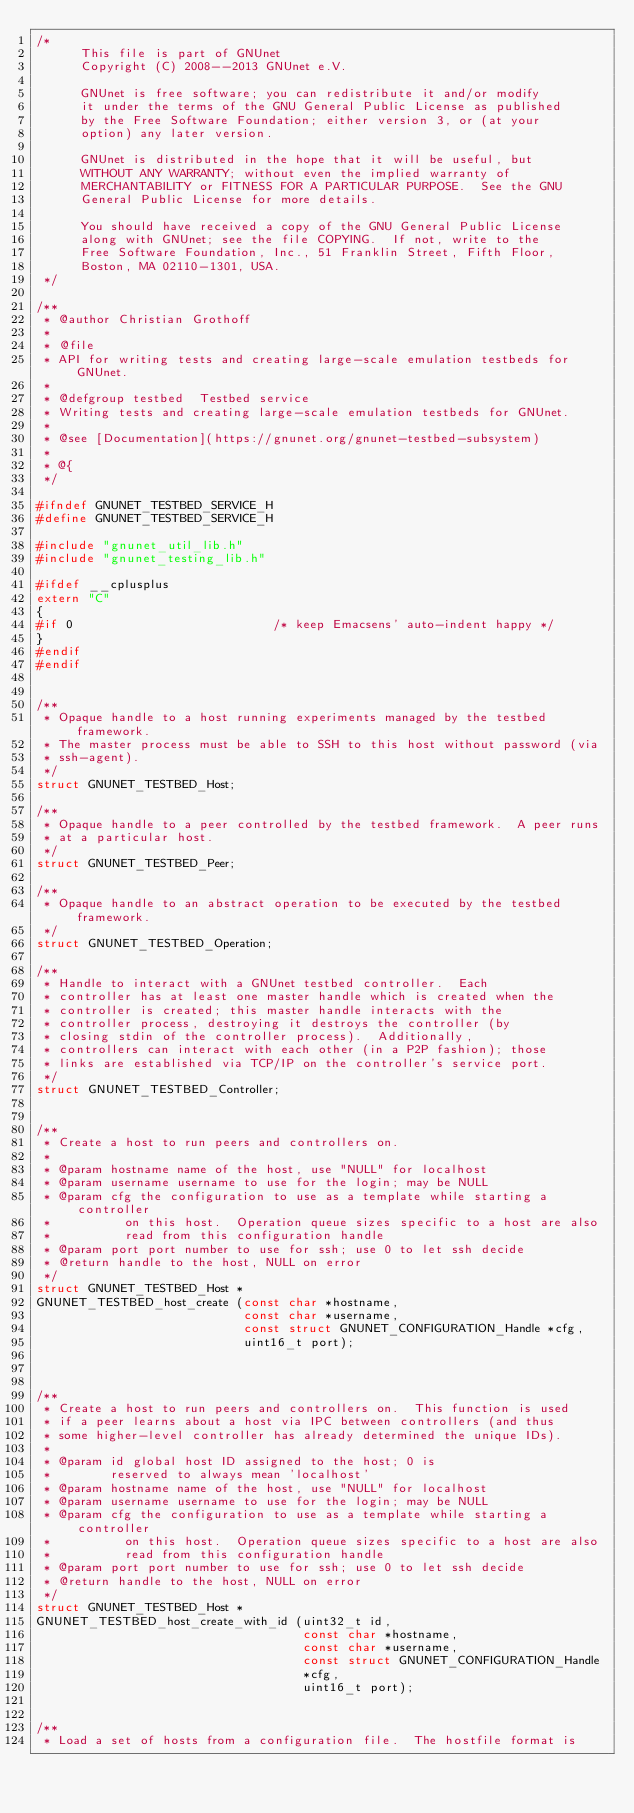Convert code to text. <code><loc_0><loc_0><loc_500><loc_500><_C_>/*
      This file is part of GNUnet
      Copyright (C) 2008--2013 GNUnet e.V.

      GNUnet is free software; you can redistribute it and/or modify
      it under the terms of the GNU General Public License as published
      by the Free Software Foundation; either version 3, or (at your
      option) any later version.

      GNUnet is distributed in the hope that it will be useful, but
      WITHOUT ANY WARRANTY; without even the implied warranty of
      MERCHANTABILITY or FITNESS FOR A PARTICULAR PURPOSE.  See the GNU
      General Public License for more details.

      You should have received a copy of the GNU General Public License
      along with GNUnet; see the file COPYING.  If not, write to the
      Free Software Foundation, Inc., 51 Franklin Street, Fifth Floor,
      Boston, MA 02110-1301, USA.
 */

/**
 * @author Christian Grothoff
 *
 * @file
 * API for writing tests and creating large-scale emulation testbeds for GNUnet.
 *
 * @defgroup testbed  Testbed service
 * Writing tests and creating large-scale emulation testbeds for GNUnet.
 *
 * @see [Documentation](https://gnunet.org/gnunet-testbed-subsystem)
 *
 * @{
 */

#ifndef GNUNET_TESTBED_SERVICE_H
#define GNUNET_TESTBED_SERVICE_H

#include "gnunet_util_lib.h"
#include "gnunet_testing_lib.h"

#ifdef __cplusplus
extern "C"
{
#if 0                           /* keep Emacsens' auto-indent happy */
}
#endif
#endif


/**
 * Opaque handle to a host running experiments managed by the testbed framework.
 * The master process must be able to SSH to this host without password (via
 * ssh-agent).
 */
struct GNUNET_TESTBED_Host;

/**
 * Opaque handle to a peer controlled by the testbed framework.  A peer runs
 * at a particular host.
 */
struct GNUNET_TESTBED_Peer;

/**
 * Opaque handle to an abstract operation to be executed by the testbed framework.
 */
struct GNUNET_TESTBED_Operation;

/**
 * Handle to interact with a GNUnet testbed controller.  Each
 * controller has at least one master handle which is created when the
 * controller is created; this master handle interacts with the
 * controller process, destroying it destroys the controller (by
 * closing stdin of the controller process).  Additionally,
 * controllers can interact with each other (in a P2P fashion); those
 * links are established via TCP/IP on the controller's service port.
 */
struct GNUNET_TESTBED_Controller;


/**
 * Create a host to run peers and controllers on.
 *
 * @param hostname name of the host, use "NULL" for localhost
 * @param username username to use for the login; may be NULL
 * @param cfg the configuration to use as a template while starting a controller
 *          on this host.  Operation queue sizes specific to a host are also
 *          read from this configuration handle
 * @param port port number to use for ssh; use 0 to let ssh decide
 * @return handle to the host, NULL on error
 */
struct GNUNET_TESTBED_Host *
GNUNET_TESTBED_host_create (const char *hostname,
                            const char *username,
                            const struct GNUNET_CONFIGURATION_Handle *cfg,
                            uint16_t port);



/**
 * Create a host to run peers and controllers on.  This function is used
 * if a peer learns about a host via IPC between controllers (and thus
 * some higher-level controller has already determined the unique IDs).
 *
 * @param id global host ID assigned to the host; 0 is
 *        reserved to always mean 'localhost'
 * @param hostname name of the host, use "NULL" for localhost
 * @param username username to use for the login; may be NULL
 * @param cfg the configuration to use as a template while starting a controller
 *          on this host.  Operation queue sizes specific to a host are also
 *          read from this configuration handle
 * @param port port number to use for ssh; use 0 to let ssh decide
 * @return handle to the host, NULL on error
 */
struct GNUNET_TESTBED_Host *
GNUNET_TESTBED_host_create_with_id (uint32_t id,
                                    const char *hostname,
                                    const char *username,
                                    const struct GNUNET_CONFIGURATION_Handle
                                    *cfg,
                                    uint16_t port);


/**
 * Load a set of hosts from a configuration file.  The hostfile format is</code> 